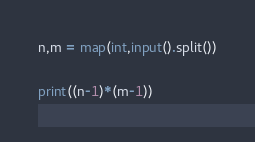Convert code to text. <code><loc_0><loc_0><loc_500><loc_500><_Python_>n,m = map(int,input().split())
  
print((n-1)*(m-1))  </code> 